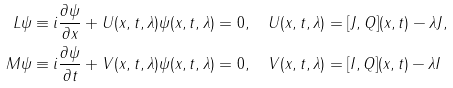Convert formula to latex. <formula><loc_0><loc_0><loc_500><loc_500>L \psi & \equiv i \frac { \partial \psi } { \partial x } + U ( x , t , \lambda ) \psi ( x , t , \lambda ) = 0 , \quad U ( x , t , \lambda ) = [ J , Q ] ( x , t ) - \lambda J , \\ M \psi & \equiv i \frac { \partial \psi } { \partial t } + V ( x , t , \lambda ) \psi ( x , t , \lambda ) = 0 , \quad V ( x , t , \lambda ) = [ I , Q ] ( x , t ) - \lambda I</formula> 